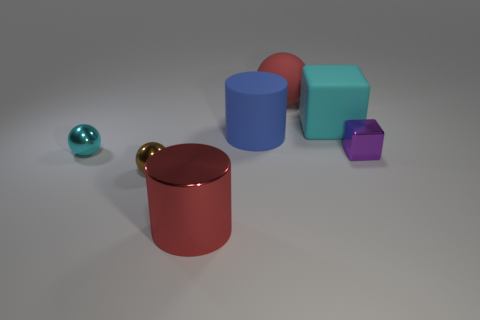What number of brown objects are the same shape as the red shiny thing?
Make the answer very short. 0. Are there fewer tiny shiny blocks that are to the right of the large cyan object than small metal objects that are in front of the big red matte object?
Your answer should be very brief. Yes. What number of big red shiny objects are to the right of the shiny thing in front of the small brown object?
Offer a very short reply. 0. Is there a tiny blue shiny thing?
Make the answer very short. No. Are there any cyan cubes made of the same material as the large ball?
Your response must be concise. Yes. Are there more rubber objects that are in front of the large cyan rubber thing than red rubber objects in front of the red metallic cylinder?
Give a very brief answer. Yes. Is the blue rubber cylinder the same size as the metallic cylinder?
Provide a succinct answer. Yes. What color is the metal thing right of the big thing that is right of the big red rubber sphere?
Provide a short and direct response. Purple. What color is the large metallic cylinder?
Your response must be concise. Red. Is there a metal thing that has the same color as the big shiny cylinder?
Provide a short and direct response. No. 